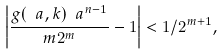<formula> <loc_0><loc_0><loc_500><loc_500>\left | \frac { g ( \ a , k ) \ a ^ { n - 1 } } { m 2 ^ { m } } - 1 \right | < 1 / 2 ^ { m + 1 } ,</formula> 